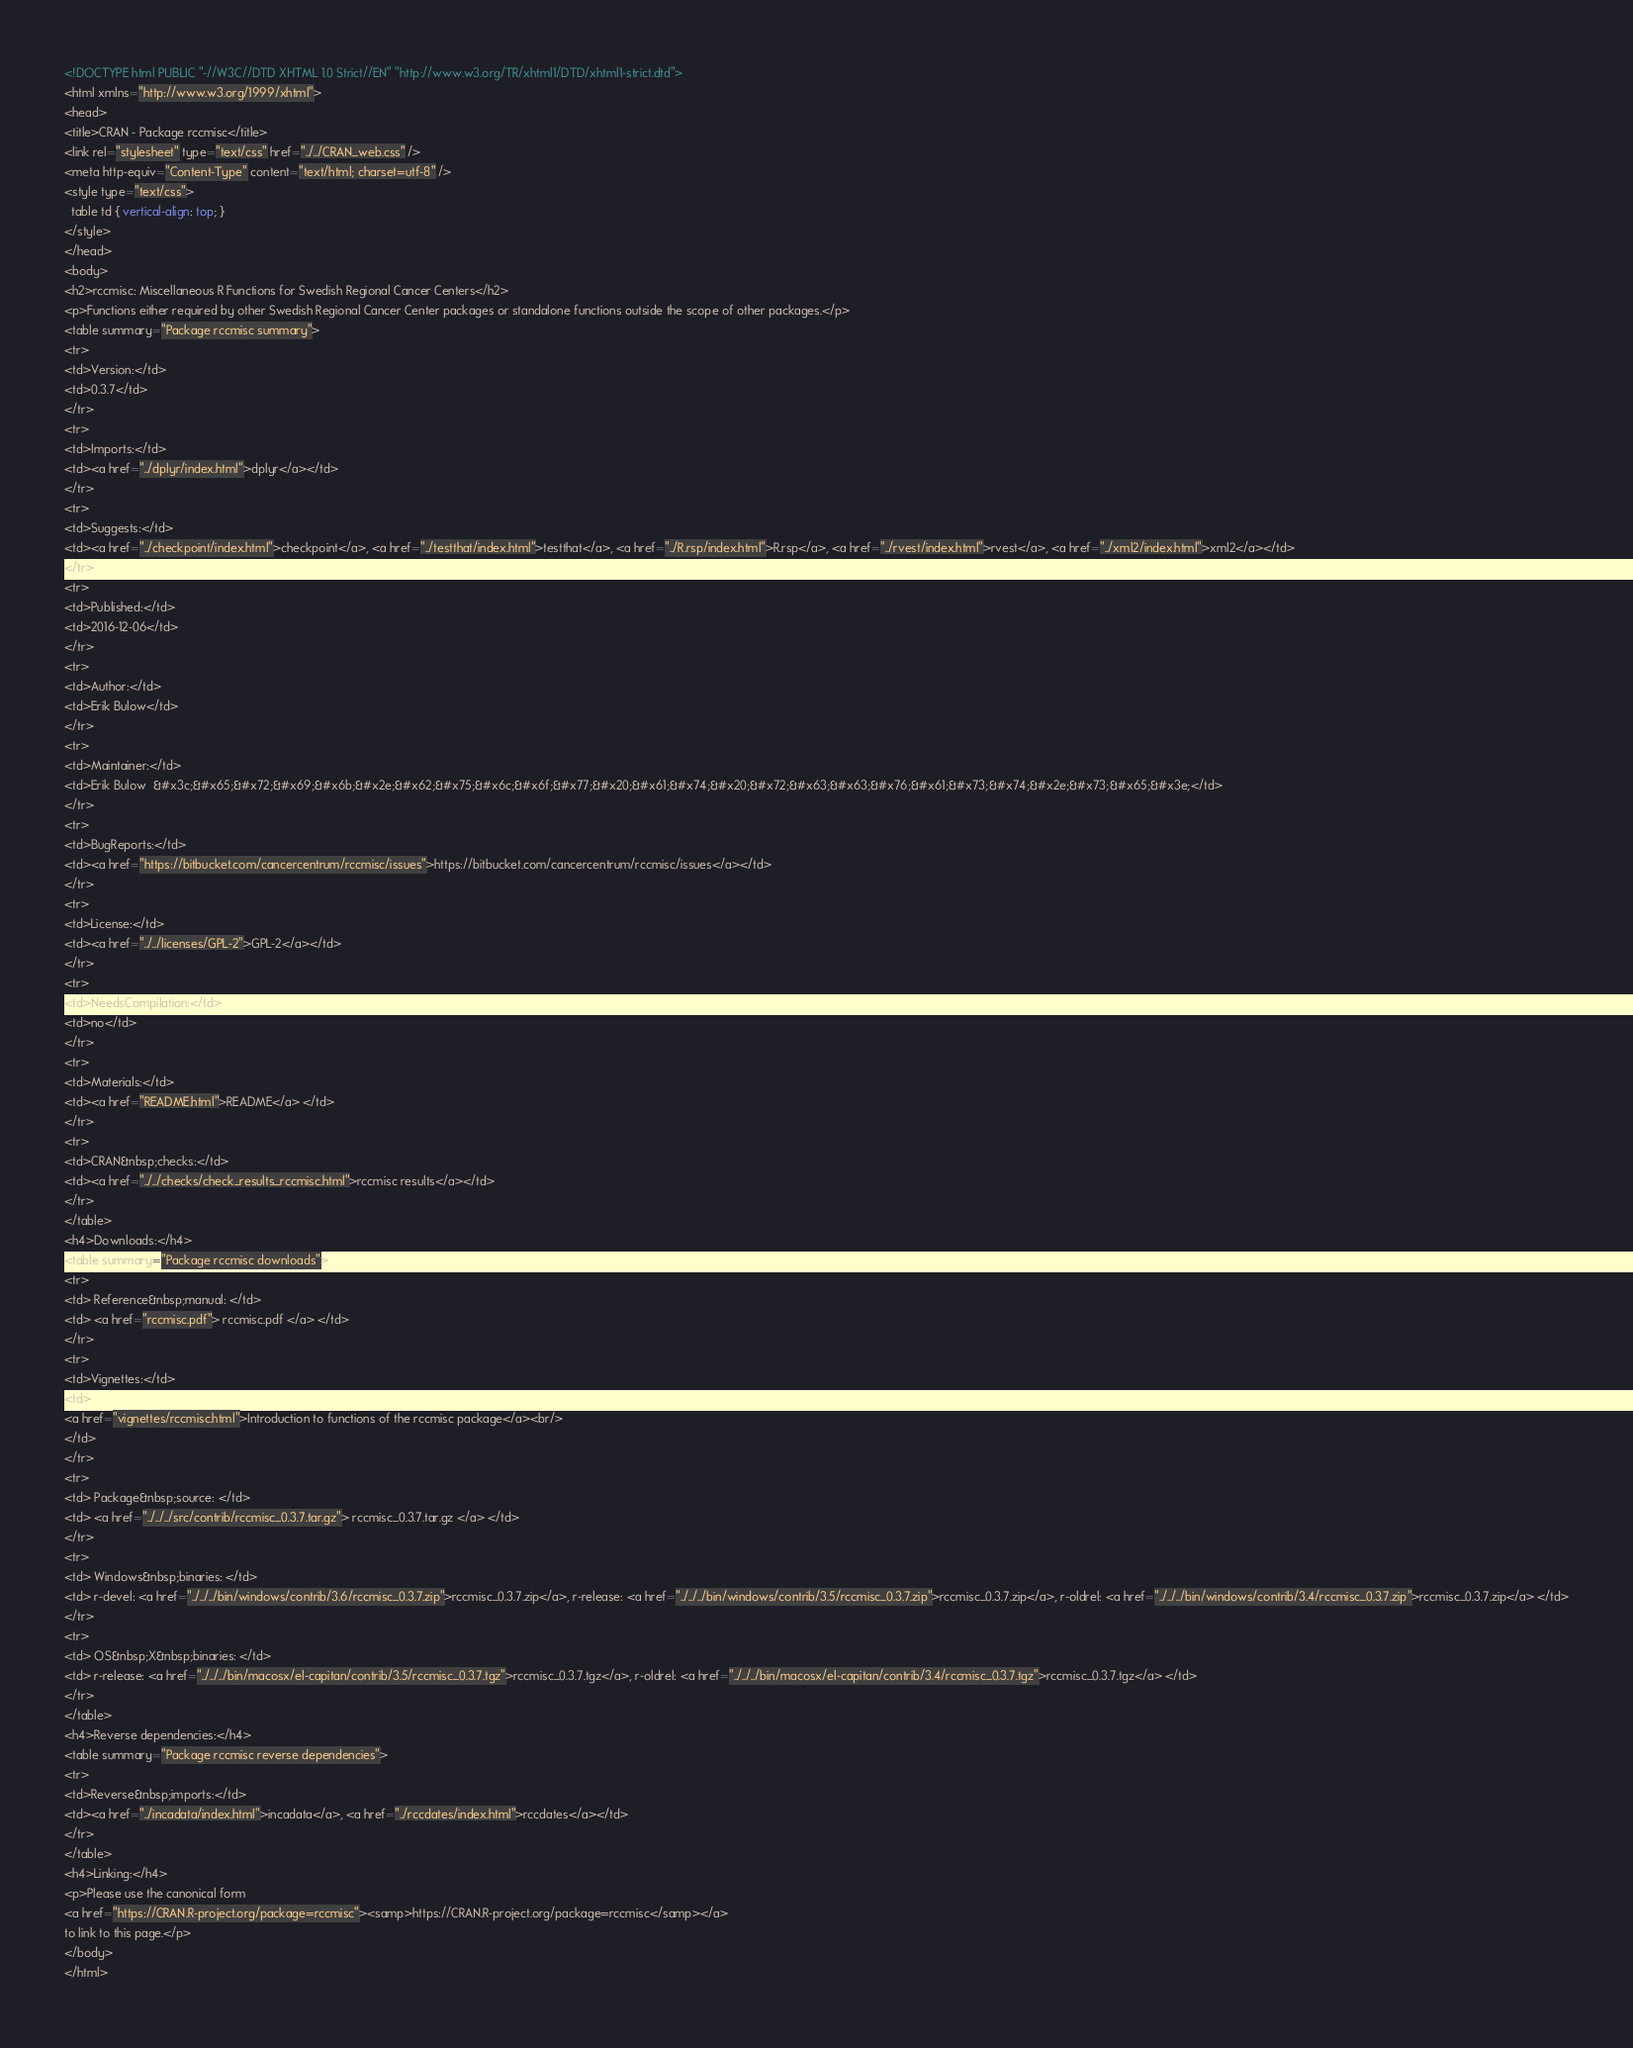Convert code to text. <code><loc_0><loc_0><loc_500><loc_500><_HTML_><!DOCTYPE html PUBLIC "-//W3C//DTD XHTML 1.0 Strict//EN" "http://www.w3.org/TR/xhtml1/DTD/xhtml1-strict.dtd">
<html xmlns="http://www.w3.org/1999/xhtml">
<head>
<title>CRAN - Package rccmisc</title>
<link rel="stylesheet" type="text/css" href="../../CRAN_web.css" />
<meta http-equiv="Content-Type" content="text/html; charset=utf-8" />
<style type="text/css">
  table td { vertical-align: top; }
</style>
</head>
<body>
<h2>rccmisc: Miscellaneous R Functions for Swedish Regional Cancer Centers</h2>
<p>Functions either required by other Swedish Regional Cancer Center packages or standalone functions outside the scope of other packages.</p>
<table summary="Package rccmisc summary">
<tr>
<td>Version:</td>
<td>0.3.7</td>
</tr>
<tr>
<td>Imports:</td>
<td><a href="../dplyr/index.html">dplyr</a></td>
</tr>
<tr>
<td>Suggests:</td>
<td><a href="../checkpoint/index.html">checkpoint</a>, <a href="../testthat/index.html">testthat</a>, <a href="../R.rsp/index.html">R.rsp</a>, <a href="../rvest/index.html">rvest</a>, <a href="../xml2/index.html">xml2</a></td>
</tr>
<tr>
<td>Published:</td>
<td>2016-12-06</td>
</tr>
<tr>
<td>Author:</td>
<td>Erik Bulow</td>
</tr>
<tr>
<td>Maintainer:</td>
<td>Erik Bulow  &#x3c;&#x65;&#x72;&#x69;&#x6b;&#x2e;&#x62;&#x75;&#x6c;&#x6f;&#x77;&#x20;&#x61;&#x74;&#x20;&#x72;&#x63;&#x63;&#x76;&#x61;&#x73;&#x74;&#x2e;&#x73;&#x65;&#x3e;</td>
</tr>
<tr>
<td>BugReports:</td>
<td><a href="https://bitbucket.com/cancercentrum/rccmisc/issues">https://bitbucket.com/cancercentrum/rccmisc/issues</a></td>
</tr>
<tr>
<td>License:</td>
<td><a href="../../licenses/GPL-2">GPL-2</a></td>
</tr>
<tr>
<td>NeedsCompilation:</td>
<td>no</td>
</tr>
<tr>
<td>Materials:</td>
<td><a href="README.html">README</a> </td>
</tr>
<tr>
<td>CRAN&nbsp;checks:</td>
<td><a href="../../checks/check_results_rccmisc.html">rccmisc results</a></td>
</tr>
</table>
<h4>Downloads:</h4>
<table summary="Package rccmisc downloads">
<tr>
<td> Reference&nbsp;manual: </td>
<td> <a href="rccmisc.pdf"> rccmisc.pdf </a> </td>
</tr>
<tr>
<td>Vignettes:</td>
<td>
<a href="vignettes/rccmisc.html">Introduction to functions of the rccmisc package</a><br/>
</td>
</tr>
<tr>
<td> Package&nbsp;source: </td>
<td> <a href="../../../src/contrib/rccmisc_0.3.7.tar.gz"> rccmisc_0.3.7.tar.gz </a> </td>
</tr>
<tr>
<td> Windows&nbsp;binaries: </td>
<td> r-devel: <a href="../../../bin/windows/contrib/3.6/rccmisc_0.3.7.zip">rccmisc_0.3.7.zip</a>, r-release: <a href="../../../bin/windows/contrib/3.5/rccmisc_0.3.7.zip">rccmisc_0.3.7.zip</a>, r-oldrel: <a href="../../../bin/windows/contrib/3.4/rccmisc_0.3.7.zip">rccmisc_0.3.7.zip</a> </td>
</tr>
<tr>
<td> OS&nbsp;X&nbsp;binaries: </td>
<td> r-release: <a href="../../../bin/macosx/el-capitan/contrib/3.5/rccmisc_0.3.7.tgz">rccmisc_0.3.7.tgz</a>, r-oldrel: <a href="../../../bin/macosx/el-capitan/contrib/3.4/rccmisc_0.3.7.tgz">rccmisc_0.3.7.tgz</a> </td>
</tr>
</table>
<h4>Reverse dependencies:</h4>
<table summary="Package rccmisc reverse dependencies">
<tr>
<td>Reverse&nbsp;imports:</td>
<td><a href="../incadata/index.html">incadata</a>, <a href="../rccdates/index.html">rccdates</a></td>
</tr>
</table>
<h4>Linking:</h4>
<p>Please use the canonical form
<a href="https://CRAN.R-project.org/package=rccmisc"><samp>https://CRAN.R-project.org/package=rccmisc</samp></a>
to link to this page.</p>
</body>
</html>
</code> 